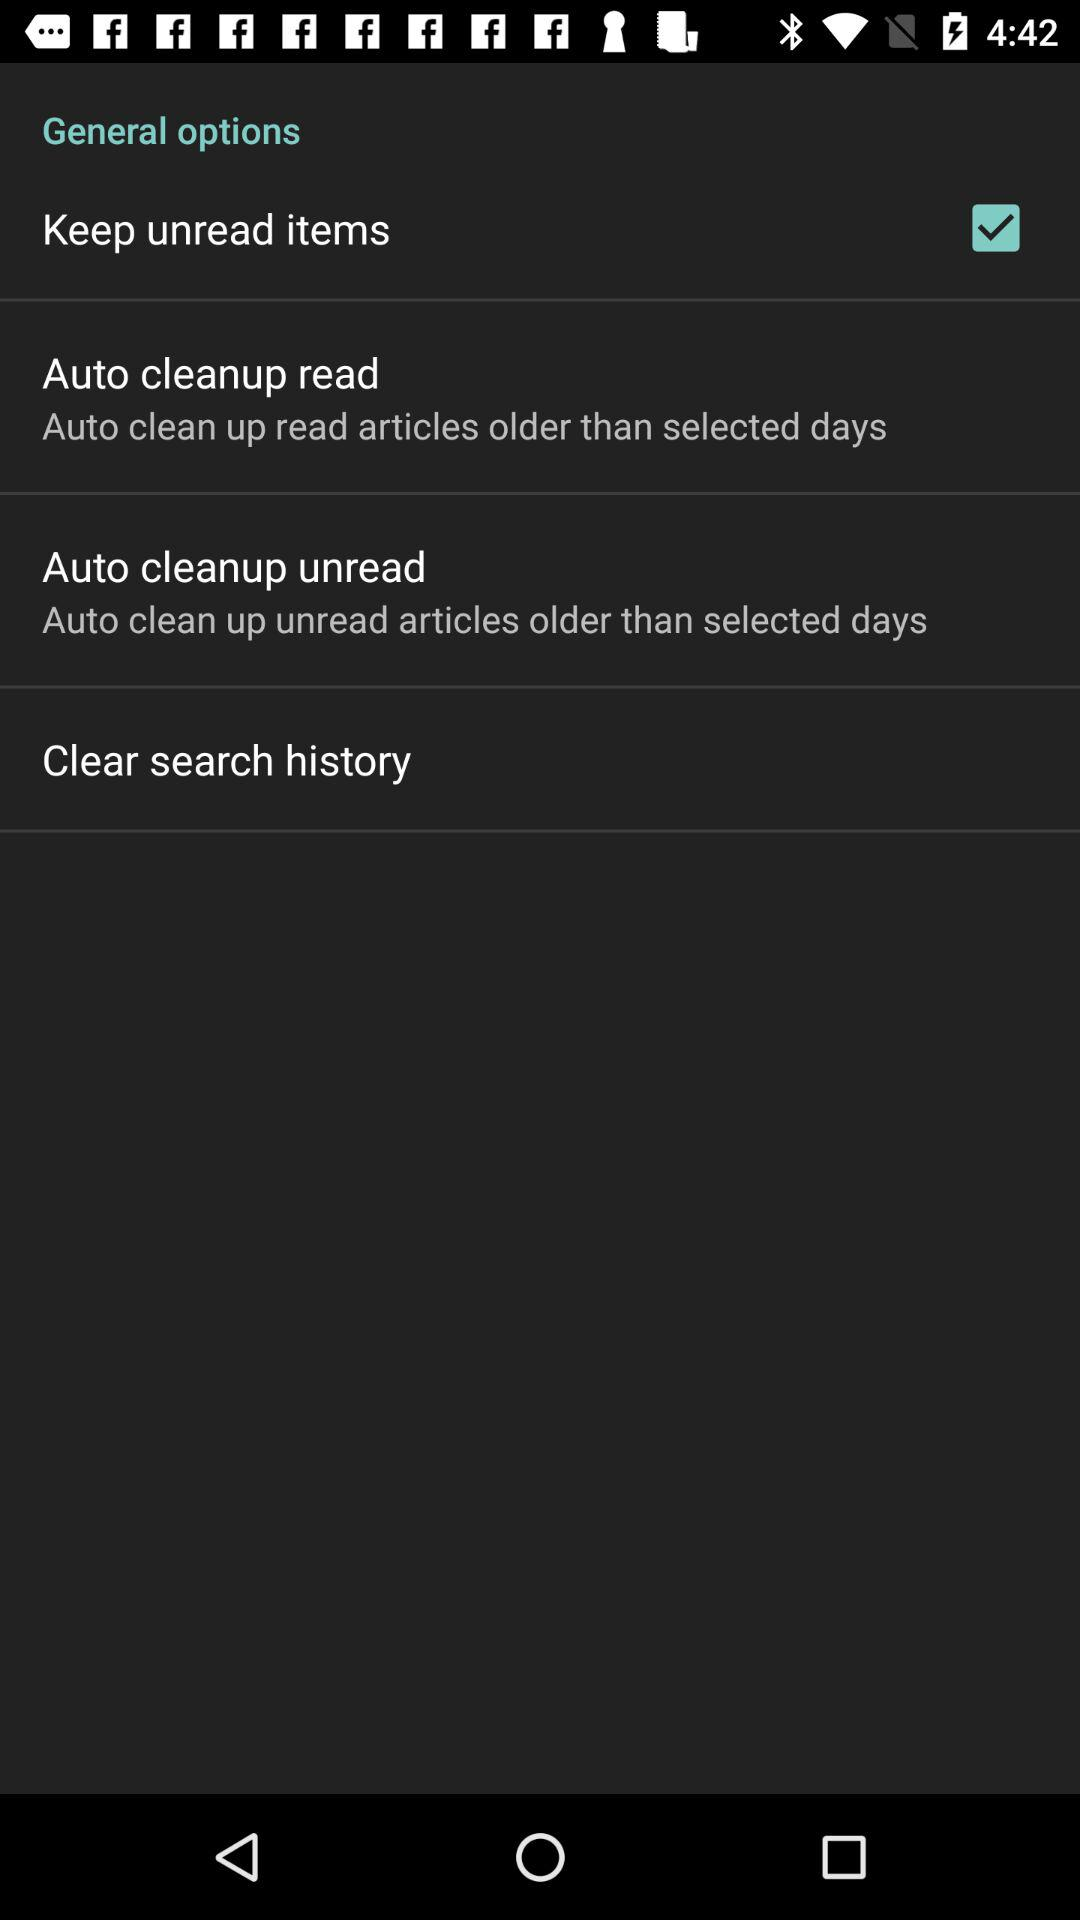What is the status of "Keep unread items"? The status is "on". 